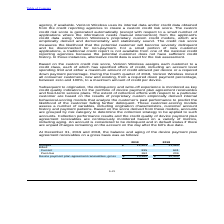According to Consolidated Communications Holdings's financial document, What is the function of customer-scoring models? assess a number of variables, including origination characteristics, customer account history and payment patterns. The document states: "further delinquent. These customer-scoring models assess a number of variables, including origination characteristics, customer account history and pa..." Also, When is an account considered to be delinquent? if there are unpaid charges remaining on the account on the day after the bill’s due date.. The document states: "considered to be delinquent and in default status if there are unpaid charges remaining on the account on the day after the bill’s due date...." Also, What was the current billed in 2019? According to the financial document, 815. The relevant text states: "Current 815 641..." Also, can you calculate: What is the increase / (decrease) in the unbilled from 2018 to 2019? Based on the calculation: 12,403 - 11,485, the result is 918. This is based on the information: "Unbilled $ 12,403 $ 11,485 Unbilled $ 12,403 $ 11,485..." The key data points involved are: 11,485, 12,403. Also, can you calculate: What is the average current billed for 2018 and 2019? To answer this question, I need to perform calculations using the financial data. The calculation is: (815 + 641) / 2, which equals 728. This is based on the information: "Current 815 641 Current 815 641..." The key data points involved are: 641, 815. Also, can you calculate: What is the increase / (decrease) in the Device payment plan agreement receivables, gross from 2018 to 2019? Based on the calculation: 13,480 - 12,335, the result is 1145. This is based on the information: "evice payment plan agreement receivables, gross $ 13,480 $ 12,335 ment plan agreement receivables, gross $ 13,480 $ 12,335..." The key data points involved are: 12,335, 13,480. 